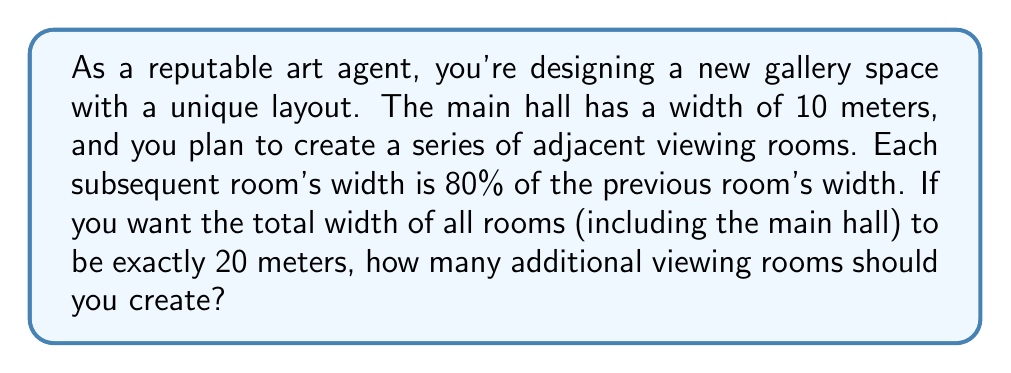Give your solution to this math problem. Let's approach this step-by-step using a geometric series:

1) Let $a$ be the width of the main hall (10 meters) and $r$ be the ratio between subsequent room widths (0.8).

2) We need to find $n$, the number of additional rooms, such that the sum of the series equals 20 meters.

3) The sum of a geometric series is given by the formula:

   $$S_n = a\frac{1-r^n}{1-r}$$

   where $S_n$ is the sum, $a$ is the first term, $r$ is the common ratio, and $n$ is the number of terms.

4) In our case, we want:

   $$20 = 10\frac{1-0.8^n}{1-0.8}$$

5) Simplify:
   
   $$20 = 10\frac{1-0.8^n}{0.2}$$
   
   $$4 = 1-0.8^n$$
   
   $$0.8^n = -3$$

6) Take the logarithm of both sides:

   $$n\log(0.8) = \log(-3)$$

7) Solve for $n$:

   $$n = \frac{\log(-3)}{\log(0.8)} \approx 4.19$$

8) Since $n$ must be a whole number and we can't exceed 20 meters, we round down to 4.

9) Verify: 
   $10 + 8 + 6.4 + 5.12 + 4.096 = 33.616$ meters, which is the closest we can get to 20 meters without exceeding it.
Answer: 4 additional viewing rooms 